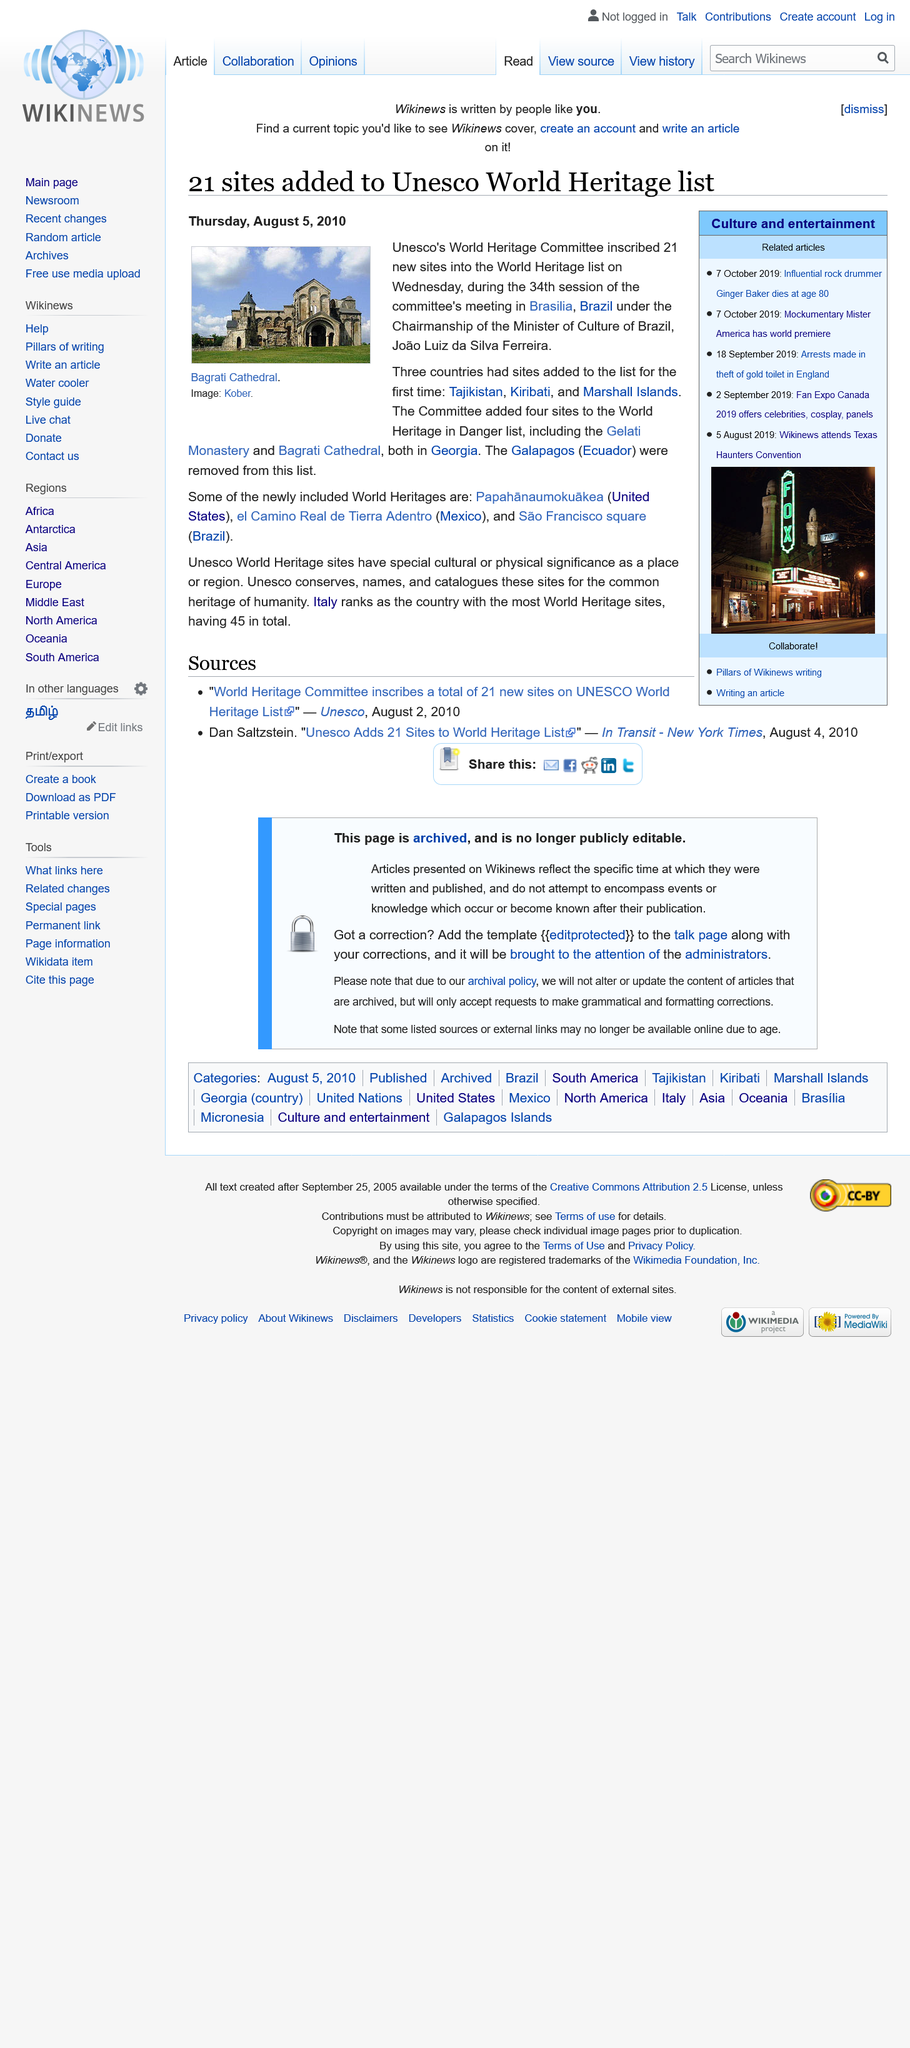Identify some key points in this picture. The Gelati Monastery and Bagrati Cathedral are located in Georgia, a country known for its stunning natural beauty and rich cultural heritage. These iconic landmarks are must-visit destinations for anyone seeking a deeper understanding of the region's rich history and vibrant traditions. Italy has the most World Heritage sites, making it a country with a rich cultural heritage. Italy has 45 world heritage sites, as declared by UNESCO. 